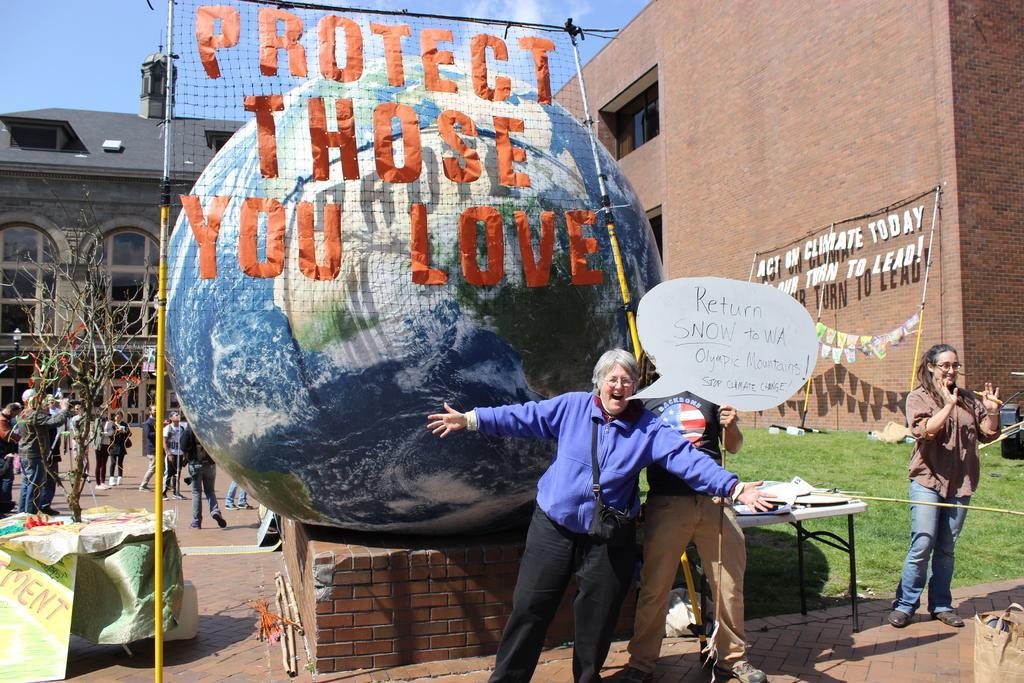Please provide a concise description of this image. In the picture I can see a group of people are standing on the ground. I can also see a round shaped object, something written on a net and the grass. In the background I can see buildings, the sky, a table which has some objects on it and some other objects on the ground. 